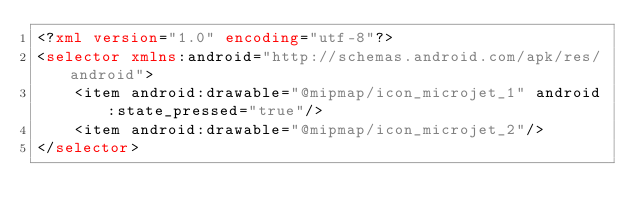<code> <loc_0><loc_0><loc_500><loc_500><_XML_><?xml version="1.0" encoding="utf-8"?>
<selector xmlns:android="http://schemas.android.com/apk/res/android">
    <item android:drawable="@mipmap/icon_microjet_1" android:state_pressed="true"/>
    <item android:drawable="@mipmap/icon_microjet_2"/>
</selector></code> 